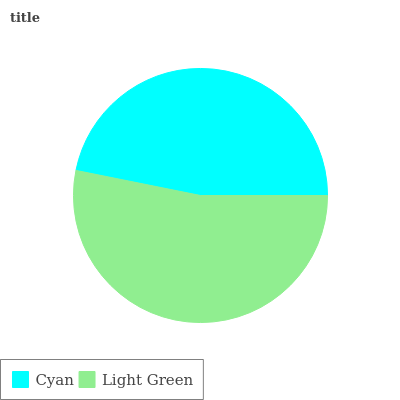Is Cyan the minimum?
Answer yes or no. Yes. Is Light Green the maximum?
Answer yes or no. Yes. Is Light Green the minimum?
Answer yes or no. No. Is Light Green greater than Cyan?
Answer yes or no. Yes. Is Cyan less than Light Green?
Answer yes or no. Yes. Is Cyan greater than Light Green?
Answer yes or no. No. Is Light Green less than Cyan?
Answer yes or no. No. Is Light Green the high median?
Answer yes or no. Yes. Is Cyan the low median?
Answer yes or no. Yes. Is Cyan the high median?
Answer yes or no. No. Is Light Green the low median?
Answer yes or no. No. 